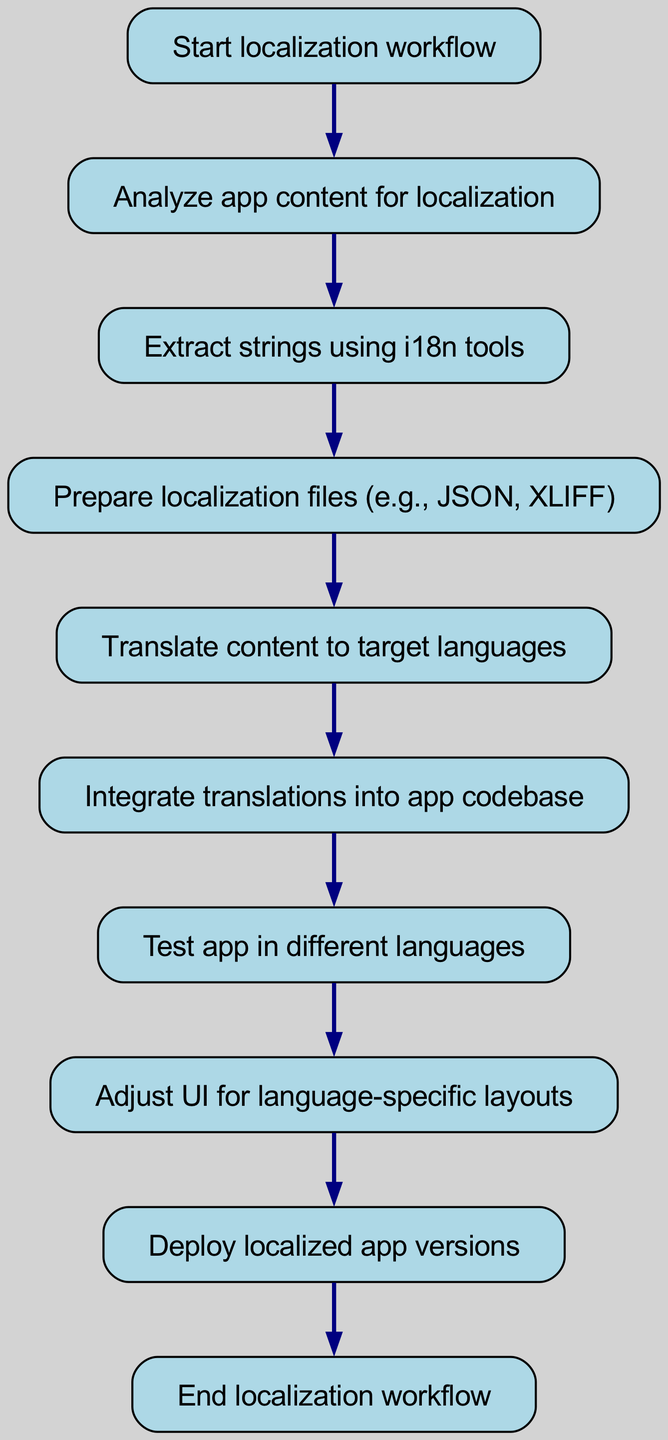What is the first step in the localization workflow? The first step in the workflow, as indicated in the diagram, is "Start localization workflow." This is the starting point from which all subsequent steps flow.
Answer: Start localization workflow How many nodes are in the diagram? Counting all the unique elements represented in the diagram, there are ten nodes: Start localization workflow, Analyze app content for localization, Extract strings using i18n tools, Prepare localization files (e.g., JSON, XLIFF), Translate content to target languages, Integrate translations into app codebase, Test app in different languages, Adjust UI for language-specific layouts, Deploy localized app versions, and End localization workflow.
Answer: Ten What step follows "Integrate translations into app codebase"? Referring to the flow of the diagram, the next step after "Integrate translations into app codebase" is "Test app in different languages." This indicates that after integration, testing is the immediate next task.
Answer: Test app in different languages Which node is directly before "Deploy localized app versions"? In the flow chart, the node that precedes "Deploy localized app versions" is "Adjust UI for language-specific layouts." This shows the sequence in which tasks must be completed.
Answer: Adjust UI for language-specific layouts What is the relationship between "Translate content to target languages" and "Prepare localization files"? The relationship is sequential; "Prepare localization files" directly follows "Translate content to target languages" in the workflow. This indicates that translations must first be prepared in localization files for further processing.
Answer: Sequential relationship What is the last step in the localization workflow? The last step indicated in the workflow is "End localization workflow." This signifies the completion of the entire localization process laid out in the diagram.
Answer: End localization workflow How many connections are depicted in the diagram? There are nine connections shown in the diagram, which indicate the flow of steps from one node to the next in the localization process.
Answer: Nine What do "Test app in different languages" and "Adjust UI for language-specific layouts" have in common? Both nodes are sequential steps in the workflow; "Test app in different languages" directly leads to "Adjust UI for language-specific layouts," indicating they are part of the same phase of testing and modifying for localization.
Answer: Sequential steps What is the purpose of the node "Extract strings using i18n tools"? This step is essential for identifying and isolating text within the app that requires translation, ensuring that all necessary strings for localization are captured for the upcoming steps.
Answer: Identify and isolate translatable text 